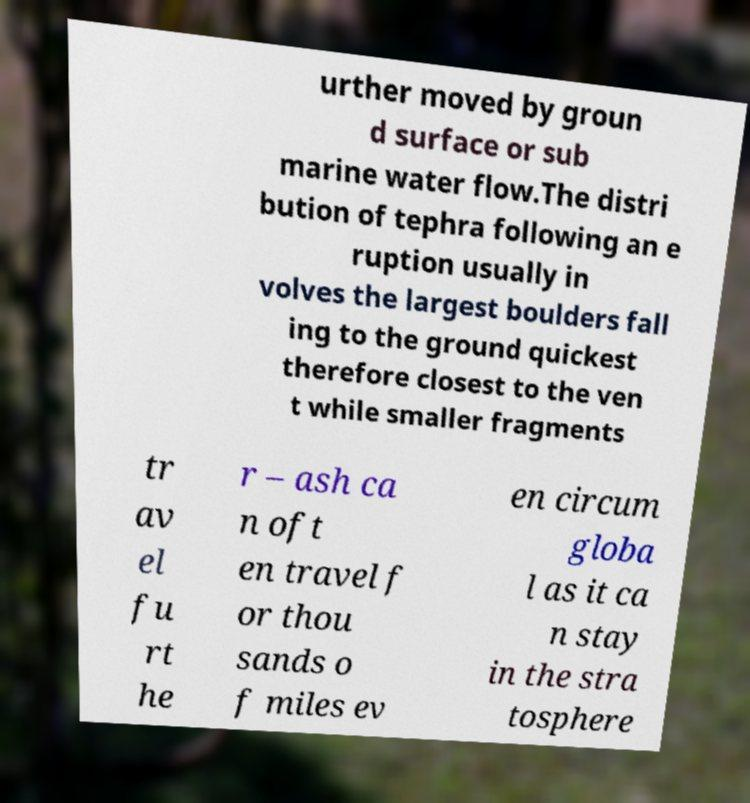What messages or text are displayed in this image? I need them in a readable, typed format. urther moved by groun d surface or sub marine water flow.The distri bution of tephra following an e ruption usually in volves the largest boulders fall ing to the ground quickest therefore closest to the ven t while smaller fragments tr av el fu rt he r – ash ca n oft en travel f or thou sands o f miles ev en circum globa l as it ca n stay in the stra tosphere 